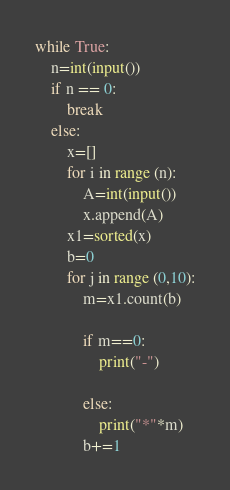<code> <loc_0><loc_0><loc_500><loc_500><_Python_>while True:
    n=int(input())
    if n == 0:
        break
    else:
        x=[]
        for i in range (n):
            A=int(input())
            x.append(A)
        x1=sorted(x)
        b=0
        for j in range (0,10):
            m=x1.count(b)
            
            if m==0:
                print("-")
                    
            else:
                print("*"*m)
            b+=1
</code> 